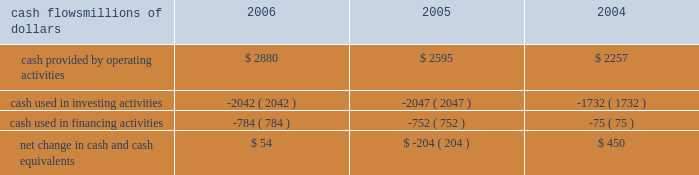Liquidity and capital resources as of december 31 , 2006 , our principal sources of liquidity included cash , cash equivalents , the sale of receivables , and our revolving credit facilities , as well as the availability of commercial paper and other sources of financing through the capital markets .
We had $ 2 billion of committed credit facilities available , of which there were no borrowings outstanding as of december 31 , 2006 , and we did not make any short-term borrowings under these facilities during the year .
The value of the outstanding undivided interest held by investors under the sale of receivables program was $ 600 million as of december 31 , 2006 .
The sale of receivables program is subject to certain requirements , including the maintenance of an investment grade bond rating .
If our bond rating were to deteriorate , it could have an adverse impact on our liquidity .
Access to commercial paper is dependent on market conditions .
Deterioration of our operating results or financial condition due to internal or external factors could negatively impact our ability to utilize commercial paper as a source of liquidity .
Liquidity through the capital markets is also dependent on our financial stability .
At both december 31 , 2006 and 2005 , we had a working capital deficit of approximately $ 1.1 billion .
A working capital deficit is common in our industry and does not indicate a lack of liquidity .
We maintain adequate resources to meet our daily cash requirements , and we have sufficient financial capacity to satisfy our current liabilities .
Financial condition cash flows millions of dollars 2006 2005 2004 .
Cash provided by operating activities 2013 higher income in 2006 generated the increased cash provided by operating activities , which was partially offset by higher income tax payments , $ 150 million in voluntary pension contributions , higher material and supply inventories , and higher management incentive payments in 2006 .
Higher income , lower management incentive payments in 2005 ( executive bonuses , which would have been paid to individuals in 2005 , were not awarded based on company performance in 2004 and bonuses for the professional workforce that were paid out in 2005 were significantly reduced ) , and working capital performance generated higher cash from operating activities in 2005 .
A voluntary pension contribution of $ 100 million in 2004 also augmented the positive year-over-year variance in 2005 as no pension contribution was made in 2005 .
This improvement was partially offset by cash received in 2004 for income tax refunds .
Cash used in investing activities 2013 an insurance settlement for the 2005 january west coast storm and lower balances for work in process decreased the amount of cash used in investing activities in 2006 .
Higher capital investments and lower proceeds from asset sales partially offset this decrease .
Increased capital spending , partially offset by higher proceeds from asset sales , increased the amount of cash used in investing activities in 2005 compared to 2004 .
Cash used in financing activities 2013 the increase in cash used in financing activities primarily resulted from lower net proceeds from equity compensation plans ( $ 189 million in 2006 compared to $ 262 million in 2005 ) .
The increase in 2005 results from debt issuances in 2004 and higher debt repayments in 2005 .
We did not issue debt in 2005 versus $ 745 million of debt issuances in 2004 , and we repaid $ 699 million of debt in 2005 compared to $ 588 million in 2004 .
The higher outflows in 2005 were partially offset by higher net proceeds from equity compensation plans ( $ 262 million in 2005 compared to $ 80 million in 2004 ) . .
What was the percentage change in cash provided by operating activities between 2005 and 2006? 
Computations: ((2880 - 2595) / 2595)
Answer: 0.10983. 